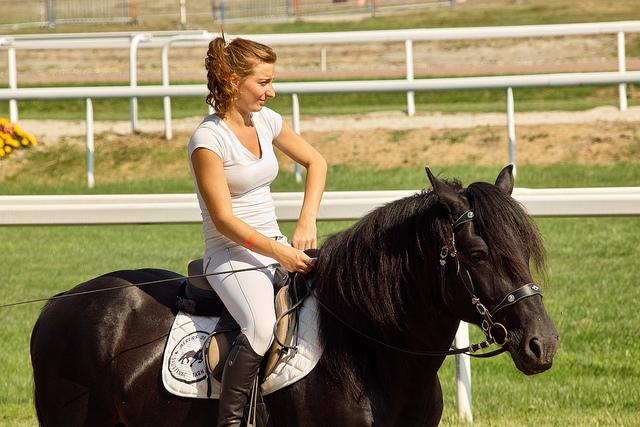Is she comfortable around horses?
Answer briefly. Yes. What type of footwear does the rider wear?
Write a very short answer. Boots. What's on the horses nose?
Be succinct. Bridle. 